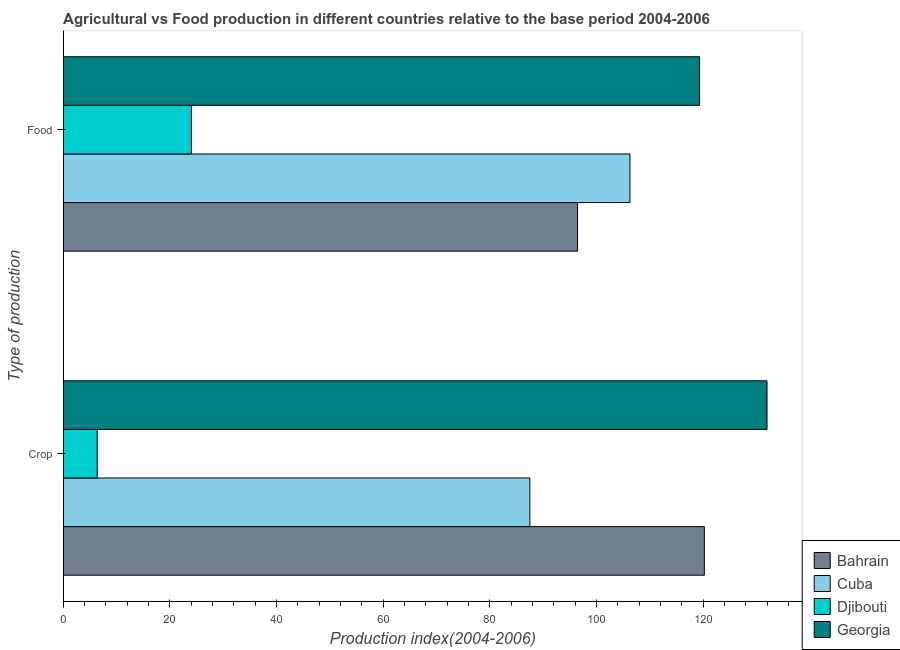How many different coloured bars are there?
Offer a very short reply. 4. Are the number of bars on each tick of the Y-axis equal?
Offer a very short reply. Yes. How many bars are there on the 1st tick from the top?
Give a very brief answer. 4. What is the label of the 2nd group of bars from the top?
Your answer should be very brief. Crop. What is the food production index in Cuba?
Ensure brevity in your answer.  106.26. Across all countries, what is the maximum crop production index?
Provide a succinct answer. 131.96. Across all countries, what is the minimum food production index?
Your answer should be very brief. 24.03. In which country was the food production index maximum?
Your answer should be very brief. Georgia. In which country was the food production index minimum?
Your response must be concise. Djibouti. What is the total crop production index in the graph?
Ensure brevity in your answer.  346.03. What is the difference between the food production index in Djibouti and that in Bahrain?
Offer a terse response. -72.41. What is the difference between the food production index in Georgia and the crop production index in Djibouti?
Provide a succinct answer. 112.95. What is the average food production index per country?
Offer a very short reply. 86.51. What is the difference between the crop production index and food production index in Georgia?
Keep it short and to the point. 12.64. In how many countries, is the food production index greater than 112 ?
Offer a very short reply. 1. What is the ratio of the crop production index in Bahrain to that in Cuba?
Give a very brief answer. 1.37. Is the food production index in Georgia less than that in Cuba?
Your answer should be compact. No. In how many countries, is the crop production index greater than the average crop production index taken over all countries?
Offer a terse response. 3. What does the 1st bar from the top in Food represents?
Provide a succinct answer. Georgia. What does the 1st bar from the bottom in Food represents?
Your response must be concise. Bahrain. Are all the bars in the graph horizontal?
Ensure brevity in your answer.  Yes. How many countries are there in the graph?
Your answer should be compact. 4. Does the graph contain any zero values?
Your response must be concise. No. Does the graph contain grids?
Your answer should be compact. No. What is the title of the graph?
Offer a terse response. Agricultural vs Food production in different countries relative to the base period 2004-2006. What is the label or title of the X-axis?
Offer a terse response. Production index(2004-2006). What is the label or title of the Y-axis?
Keep it short and to the point. Type of production. What is the Production index(2004-2006) of Bahrain in Crop?
Your answer should be compact. 120.21. What is the Production index(2004-2006) in Cuba in Crop?
Your response must be concise. 87.49. What is the Production index(2004-2006) of Djibouti in Crop?
Provide a short and direct response. 6.37. What is the Production index(2004-2006) of Georgia in Crop?
Your answer should be compact. 131.96. What is the Production index(2004-2006) in Bahrain in Food?
Offer a terse response. 96.44. What is the Production index(2004-2006) of Cuba in Food?
Provide a succinct answer. 106.26. What is the Production index(2004-2006) of Djibouti in Food?
Make the answer very short. 24.03. What is the Production index(2004-2006) in Georgia in Food?
Provide a succinct answer. 119.32. Across all Type of production, what is the maximum Production index(2004-2006) of Bahrain?
Keep it short and to the point. 120.21. Across all Type of production, what is the maximum Production index(2004-2006) in Cuba?
Offer a very short reply. 106.26. Across all Type of production, what is the maximum Production index(2004-2006) of Djibouti?
Give a very brief answer. 24.03. Across all Type of production, what is the maximum Production index(2004-2006) in Georgia?
Ensure brevity in your answer.  131.96. Across all Type of production, what is the minimum Production index(2004-2006) of Bahrain?
Offer a terse response. 96.44. Across all Type of production, what is the minimum Production index(2004-2006) of Cuba?
Your answer should be very brief. 87.49. Across all Type of production, what is the minimum Production index(2004-2006) in Djibouti?
Provide a short and direct response. 6.37. Across all Type of production, what is the minimum Production index(2004-2006) of Georgia?
Your answer should be compact. 119.32. What is the total Production index(2004-2006) in Bahrain in the graph?
Keep it short and to the point. 216.65. What is the total Production index(2004-2006) of Cuba in the graph?
Your answer should be compact. 193.75. What is the total Production index(2004-2006) in Djibouti in the graph?
Your answer should be compact. 30.4. What is the total Production index(2004-2006) of Georgia in the graph?
Your answer should be very brief. 251.28. What is the difference between the Production index(2004-2006) of Bahrain in Crop and that in Food?
Ensure brevity in your answer.  23.77. What is the difference between the Production index(2004-2006) in Cuba in Crop and that in Food?
Ensure brevity in your answer.  -18.77. What is the difference between the Production index(2004-2006) of Djibouti in Crop and that in Food?
Give a very brief answer. -17.66. What is the difference between the Production index(2004-2006) of Georgia in Crop and that in Food?
Offer a terse response. 12.64. What is the difference between the Production index(2004-2006) of Bahrain in Crop and the Production index(2004-2006) of Cuba in Food?
Provide a short and direct response. 13.95. What is the difference between the Production index(2004-2006) in Bahrain in Crop and the Production index(2004-2006) in Djibouti in Food?
Your answer should be very brief. 96.18. What is the difference between the Production index(2004-2006) of Bahrain in Crop and the Production index(2004-2006) of Georgia in Food?
Your answer should be very brief. 0.89. What is the difference between the Production index(2004-2006) of Cuba in Crop and the Production index(2004-2006) of Djibouti in Food?
Your answer should be very brief. 63.46. What is the difference between the Production index(2004-2006) in Cuba in Crop and the Production index(2004-2006) in Georgia in Food?
Provide a short and direct response. -31.83. What is the difference between the Production index(2004-2006) of Djibouti in Crop and the Production index(2004-2006) of Georgia in Food?
Ensure brevity in your answer.  -112.95. What is the average Production index(2004-2006) in Bahrain per Type of production?
Your response must be concise. 108.33. What is the average Production index(2004-2006) of Cuba per Type of production?
Offer a terse response. 96.88. What is the average Production index(2004-2006) of Djibouti per Type of production?
Your response must be concise. 15.2. What is the average Production index(2004-2006) in Georgia per Type of production?
Provide a short and direct response. 125.64. What is the difference between the Production index(2004-2006) of Bahrain and Production index(2004-2006) of Cuba in Crop?
Make the answer very short. 32.72. What is the difference between the Production index(2004-2006) of Bahrain and Production index(2004-2006) of Djibouti in Crop?
Your answer should be very brief. 113.84. What is the difference between the Production index(2004-2006) of Bahrain and Production index(2004-2006) of Georgia in Crop?
Offer a very short reply. -11.75. What is the difference between the Production index(2004-2006) in Cuba and Production index(2004-2006) in Djibouti in Crop?
Your response must be concise. 81.12. What is the difference between the Production index(2004-2006) of Cuba and Production index(2004-2006) of Georgia in Crop?
Make the answer very short. -44.47. What is the difference between the Production index(2004-2006) in Djibouti and Production index(2004-2006) in Georgia in Crop?
Offer a terse response. -125.59. What is the difference between the Production index(2004-2006) in Bahrain and Production index(2004-2006) in Cuba in Food?
Your answer should be very brief. -9.82. What is the difference between the Production index(2004-2006) of Bahrain and Production index(2004-2006) of Djibouti in Food?
Keep it short and to the point. 72.41. What is the difference between the Production index(2004-2006) in Bahrain and Production index(2004-2006) in Georgia in Food?
Ensure brevity in your answer.  -22.88. What is the difference between the Production index(2004-2006) in Cuba and Production index(2004-2006) in Djibouti in Food?
Keep it short and to the point. 82.23. What is the difference between the Production index(2004-2006) of Cuba and Production index(2004-2006) of Georgia in Food?
Your answer should be very brief. -13.06. What is the difference between the Production index(2004-2006) of Djibouti and Production index(2004-2006) of Georgia in Food?
Your answer should be compact. -95.29. What is the ratio of the Production index(2004-2006) in Bahrain in Crop to that in Food?
Your answer should be very brief. 1.25. What is the ratio of the Production index(2004-2006) of Cuba in Crop to that in Food?
Give a very brief answer. 0.82. What is the ratio of the Production index(2004-2006) of Djibouti in Crop to that in Food?
Your response must be concise. 0.27. What is the ratio of the Production index(2004-2006) of Georgia in Crop to that in Food?
Make the answer very short. 1.11. What is the difference between the highest and the second highest Production index(2004-2006) in Bahrain?
Make the answer very short. 23.77. What is the difference between the highest and the second highest Production index(2004-2006) of Cuba?
Your answer should be compact. 18.77. What is the difference between the highest and the second highest Production index(2004-2006) of Djibouti?
Your answer should be very brief. 17.66. What is the difference between the highest and the second highest Production index(2004-2006) of Georgia?
Provide a short and direct response. 12.64. What is the difference between the highest and the lowest Production index(2004-2006) of Bahrain?
Ensure brevity in your answer.  23.77. What is the difference between the highest and the lowest Production index(2004-2006) in Cuba?
Make the answer very short. 18.77. What is the difference between the highest and the lowest Production index(2004-2006) in Djibouti?
Provide a short and direct response. 17.66. What is the difference between the highest and the lowest Production index(2004-2006) in Georgia?
Ensure brevity in your answer.  12.64. 